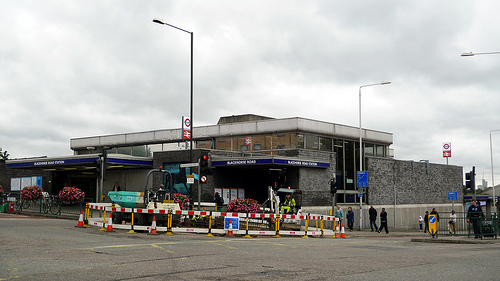<image>
Is there a pole to the right of the building? No. The pole is not to the right of the building. The horizontal positioning shows a different relationship. 